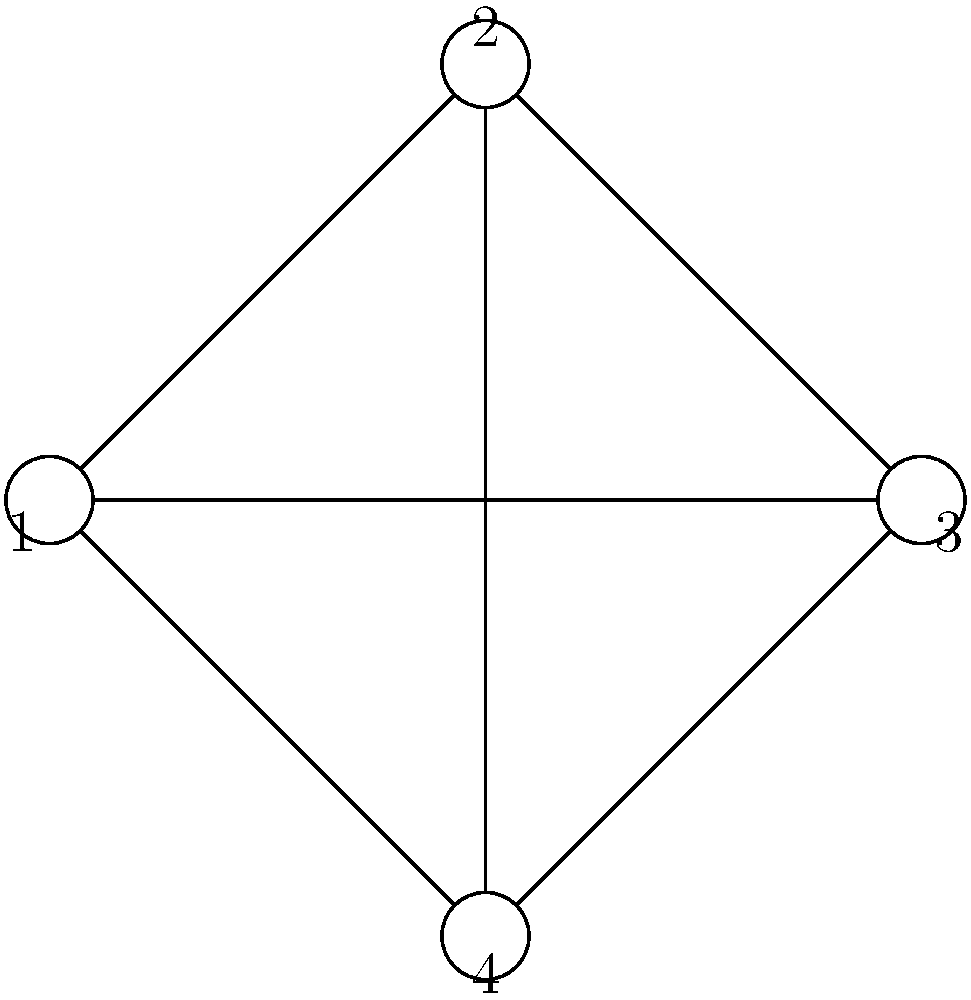Consider the graph shown above. What is the chromatic number of this graph, and how does this relate to the efficiency of resource allocation in a system where each vertex represents a task and each edge represents a conflict between tasks? To determine the chromatic number and its relation to resource allocation, let's follow these steps:

1. Analyze the graph structure:
   The graph is a complete graph K4 (all vertices are connected to each other).

2. Determine the chromatic number:
   - Each vertex must have a different color from its neighbors.
   - Since each vertex is connected to all others, we need 4 colors.
   - Therefore, the chromatic number χ(G) = 4.

3. Relation to resource allocation:
   - Each color represents a distinct resource or time slot.
   - Tasks (vertices) connected by an edge cannot use the same resource simultaneously.
   - The chromatic number represents the minimum number of resources or time slots needed to complete all tasks without conflicts.

4. Efficiency implications:
   - A lower chromatic number would indicate a more efficient allocation, as fewer resources are required.
   - In this case, χ(G) = 4 means we need at least 4 distinct resources or time slots to complete all tasks.
   - This is the most efficient allocation possible for this conflict graph, as no two tasks can share a resource.

5. Algorithmic considerations:
   - Finding the chromatic number is NP-hard for general graphs.
   - For special graph structures, efficient algorithms exist (e.g., greedy coloring for interval graphs).
   - In practice, heuristic algorithms are often used for large-scale resource allocation problems.

The chromatic number directly relates to the minimum number of resources needed, showcasing the importance of graph coloring algorithms in optimizing resource allocation for conflicting tasks.
Answer: Chromatic number is 4; represents minimum resources needed for conflict-free allocation. 